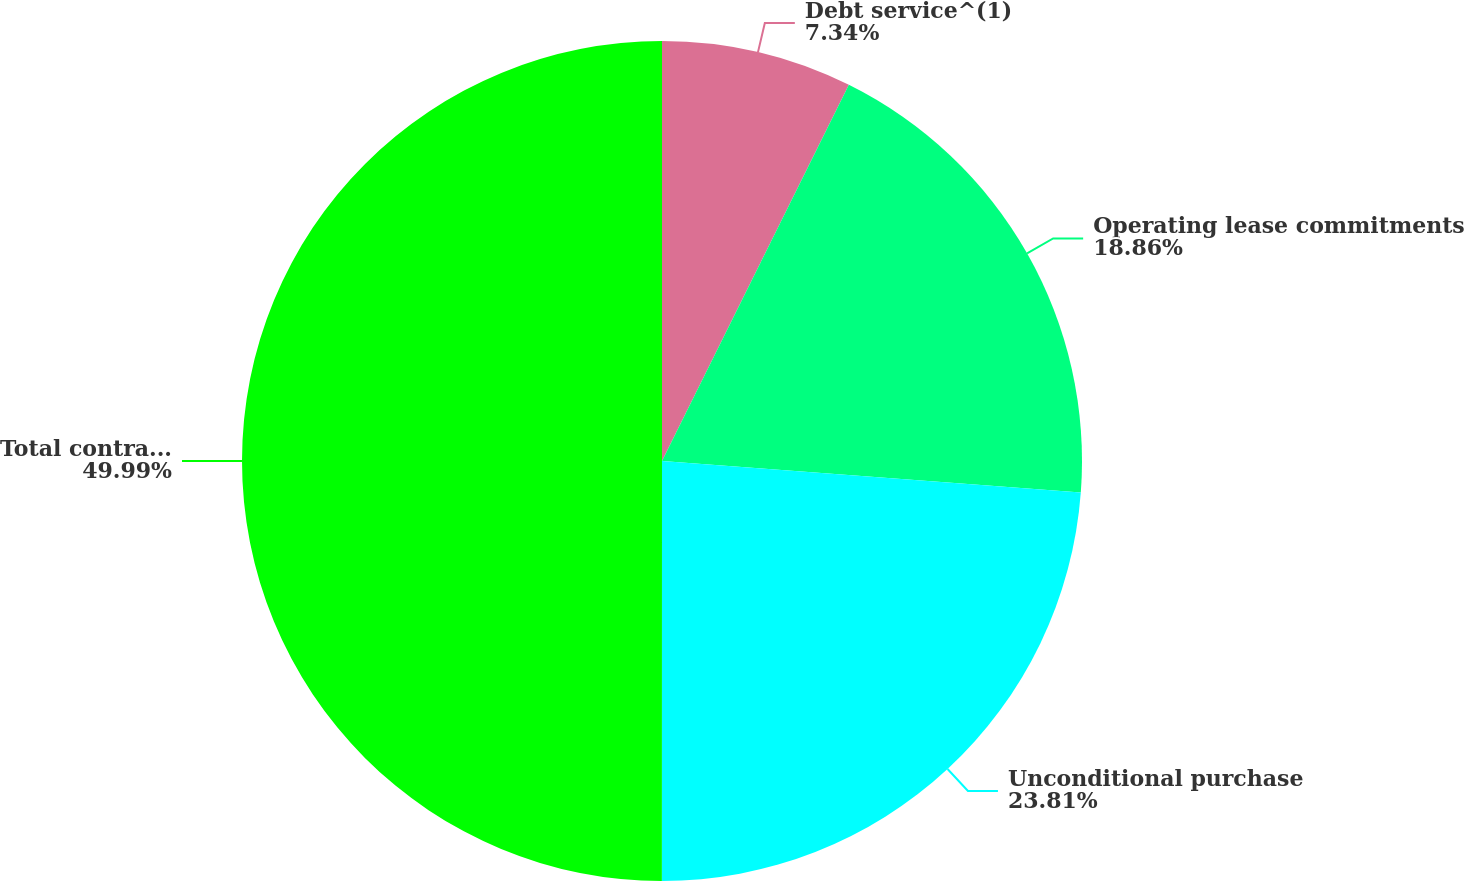Convert chart to OTSL. <chart><loc_0><loc_0><loc_500><loc_500><pie_chart><fcel>Debt service^(1)<fcel>Operating lease commitments<fcel>Unconditional purchase<fcel>Total contractual obligations<nl><fcel>7.34%<fcel>18.86%<fcel>23.81%<fcel>50.0%<nl></chart> 